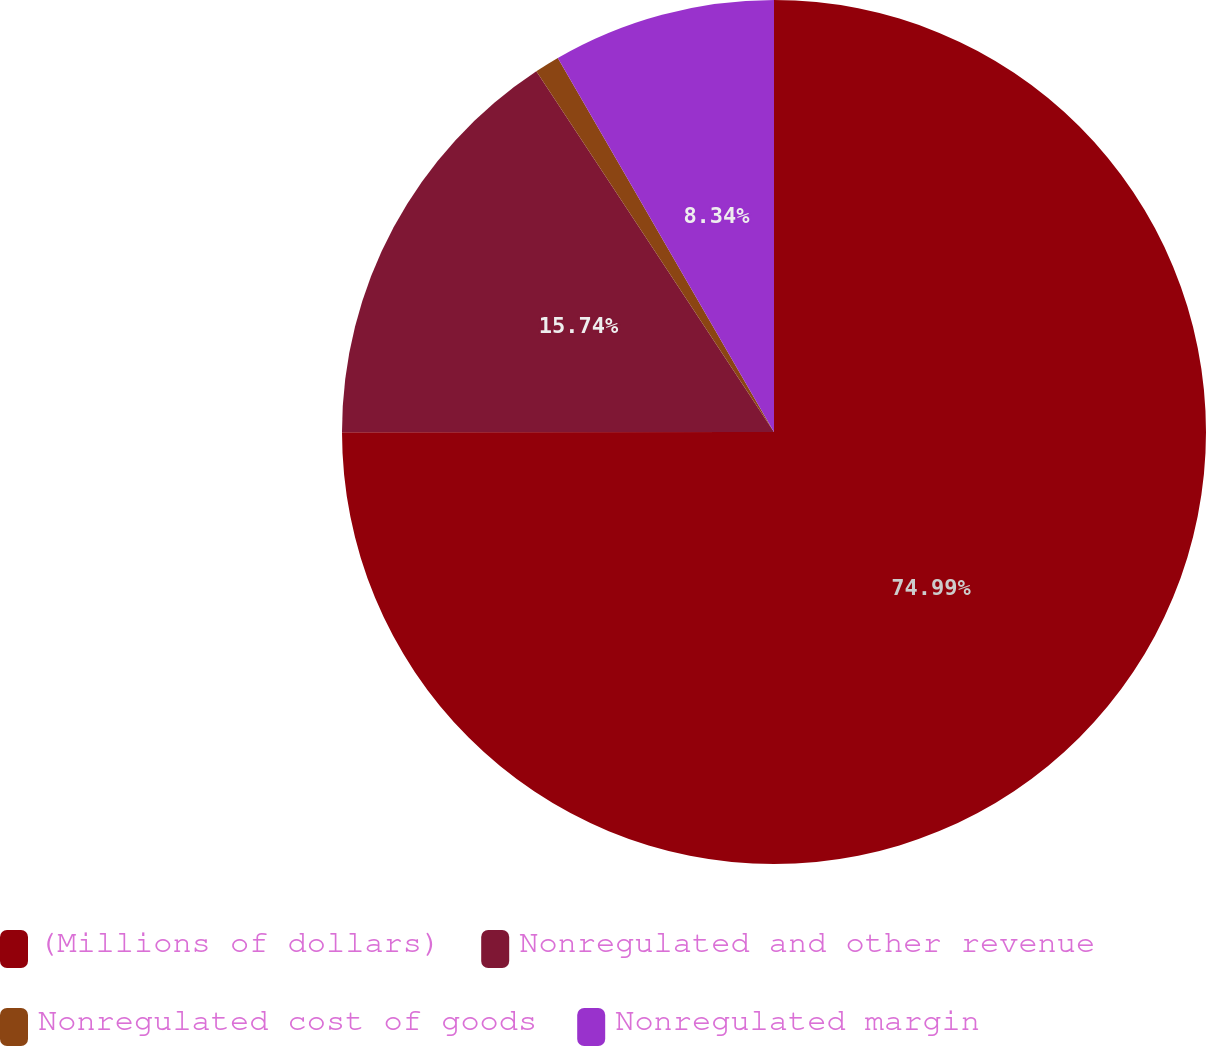<chart> <loc_0><loc_0><loc_500><loc_500><pie_chart><fcel>(Millions of dollars)<fcel>Nonregulated and other revenue<fcel>Nonregulated cost of goods<fcel>Nonregulated margin<nl><fcel>74.98%<fcel>15.74%<fcel>0.93%<fcel>8.34%<nl></chart> 